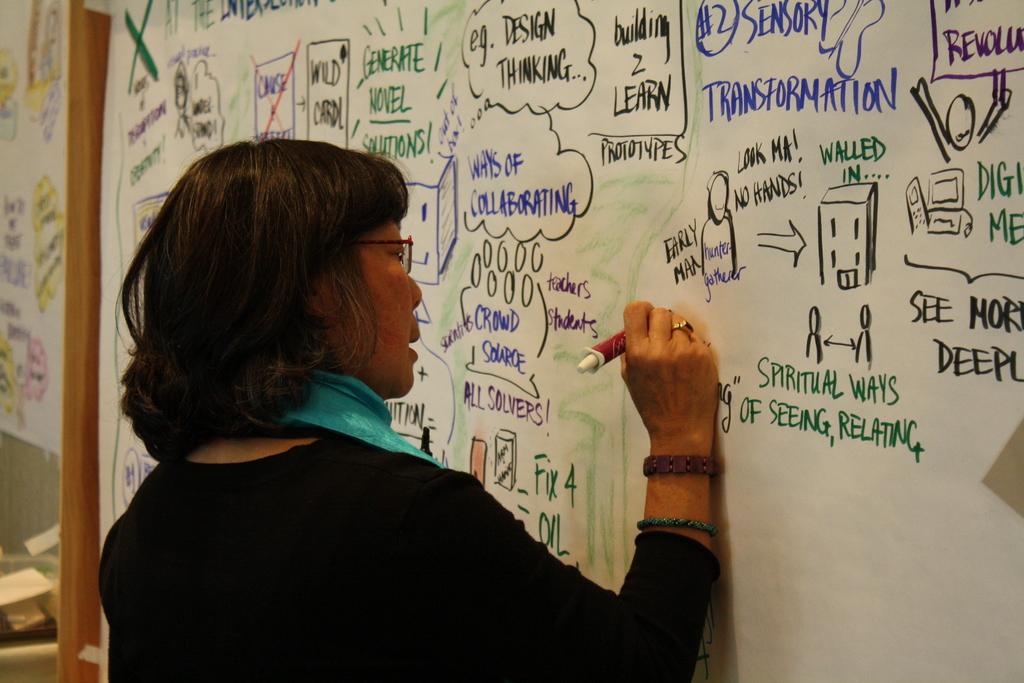What kind of transformation?
Ensure brevity in your answer.  Sensory. 